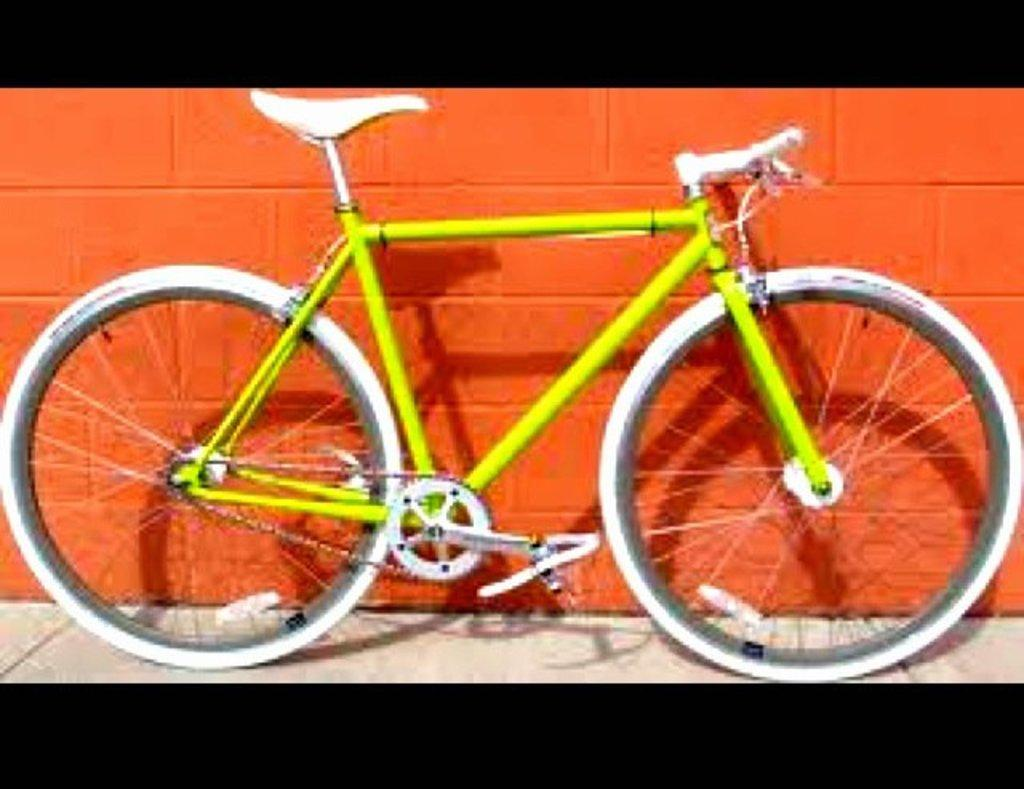What type of vehicle is in the image? There is a cycle in the image. What color is the cycle? The cycle is green in color. What is located behind the cycle in the image? There is a wall behind the cycle. How many beans are on the cycle in the image? There are no beans present in the image. What type of base does the cycle have in the image? The image does not provide information about the base of the cycle. 